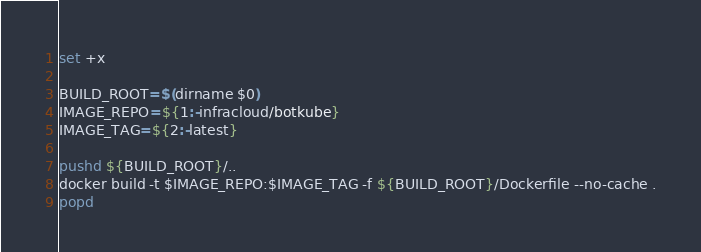Convert code to text. <code><loc_0><loc_0><loc_500><loc_500><_Bash_>set +x

BUILD_ROOT=$(dirname $0)
IMAGE_REPO=${1:-infracloud/botkube}
IMAGE_TAG=${2:-latest}

pushd ${BUILD_ROOT}/..
docker build -t $IMAGE_REPO:$IMAGE_TAG -f ${BUILD_ROOT}/Dockerfile --no-cache .
popd
</code> 